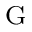Convert formula to latex. <formula><loc_0><loc_0><loc_500><loc_500>^ { G }</formula> 